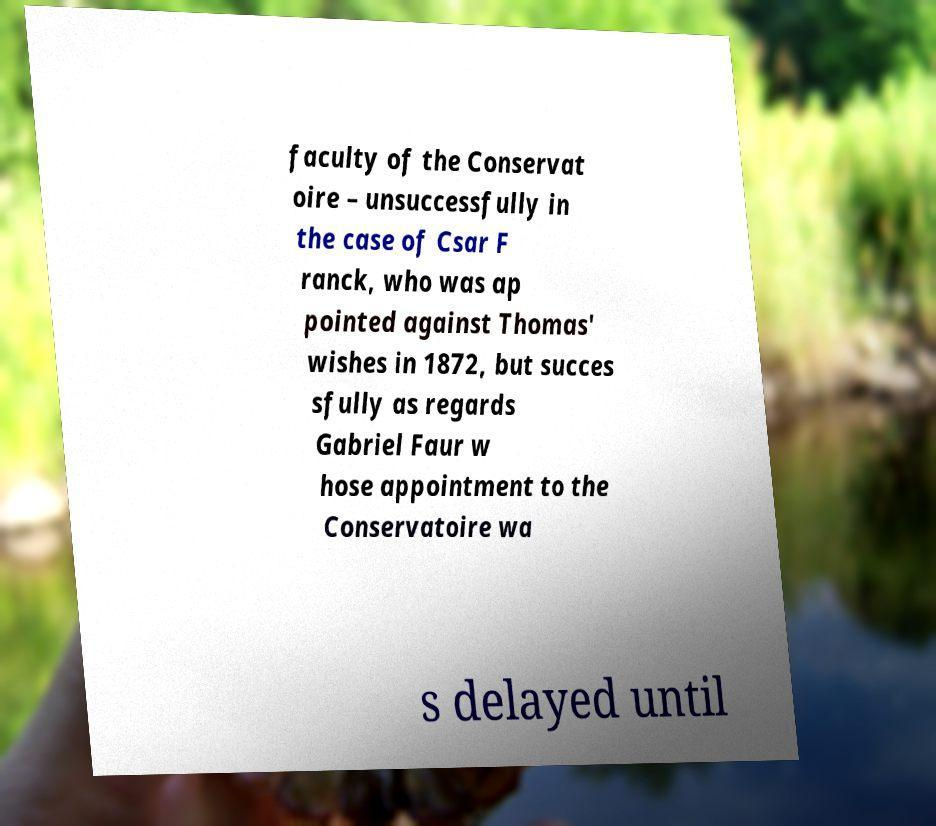Can you read and provide the text displayed in the image?This photo seems to have some interesting text. Can you extract and type it out for me? faculty of the Conservat oire – unsuccessfully in the case of Csar F ranck, who was ap pointed against Thomas' wishes in 1872, but succes sfully as regards Gabriel Faur w hose appointment to the Conservatoire wa s delayed until 